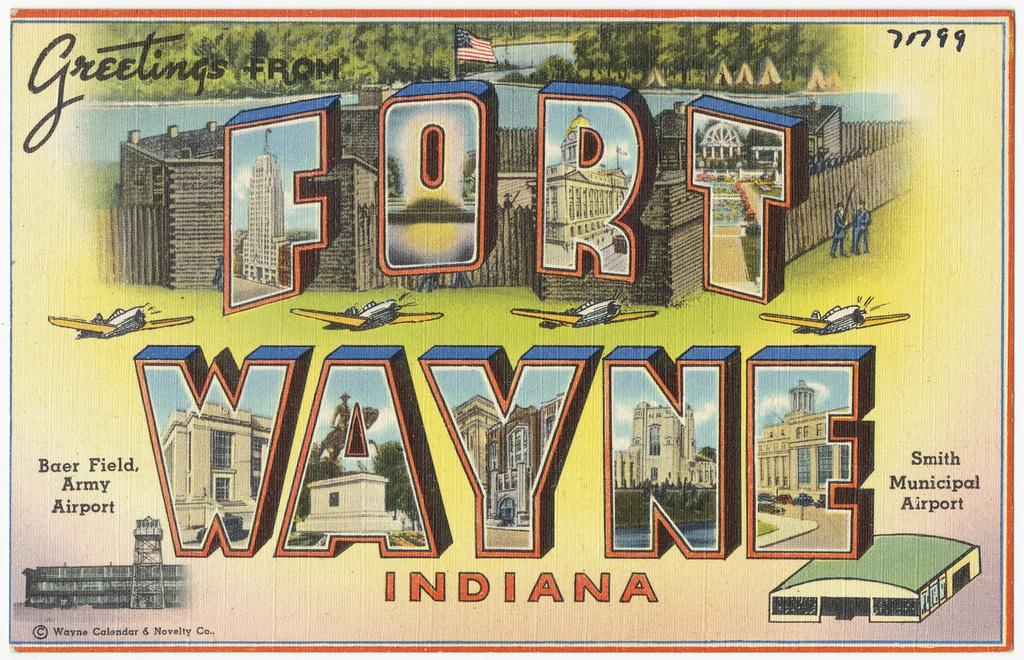<image>
Describe the image concisely. A postcard that is from Fort Wayne Indiana. 